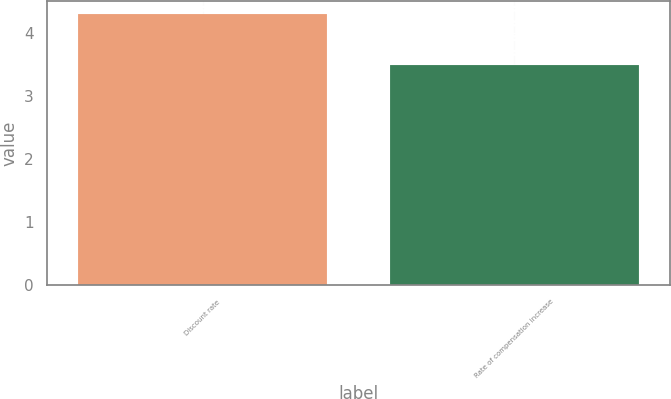Convert chart. <chart><loc_0><loc_0><loc_500><loc_500><bar_chart><fcel>Discount rate<fcel>Rate of compensation increase<nl><fcel>4.3<fcel>3.5<nl></chart> 